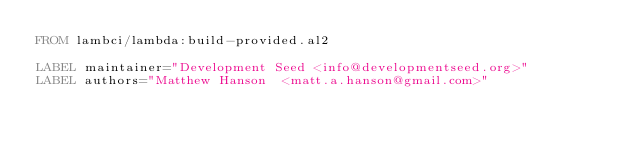Convert code to text. <code><loc_0><loc_0><loc_500><loc_500><_Dockerfile_>FROM lambci/lambda:build-provided.al2

LABEL maintainer="Development Seed <info@developmentseed.org>"
LABEL authors="Matthew Hanson  <matt.a.hanson@gmail.com>"
</code> 